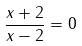<formula> <loc_0><loc_0><loc_500><loc_500>\frac { x + 2 } { x - 2 } = 0</formula> 